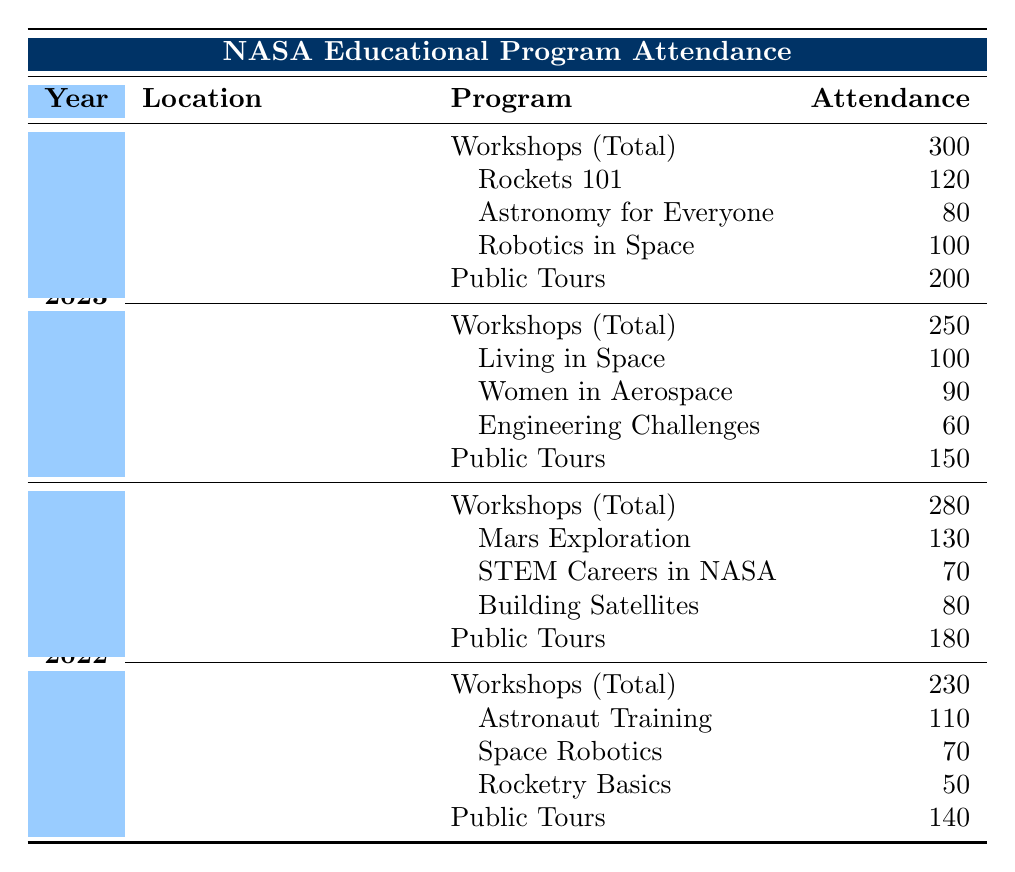What was the total attendance for workshops at Kennedy Space Center in 2023? The table shows that for 2023 at Kennedy Space Center, the total attendance for workshops is 300.
Answer: 300 How many attendees participated in the "Women in Aerospace" program at Johnson Space Center in 2023? Referring to the table for 2023 at Johnson Space Center, the attendance for the "Women in Aerospace" program is listed as 90.
Answer: 90 Which year had higher public tour attendance at the Kennedy Space Center, 2022 or 2023? The public tour attendance for 2022 was 180 and for 2023 was 200. Since 200 is greater than 180, 2023 had higher public tour attendance.
Answer: 2023 What is the total attendance for all workshops held at the Johnson Space Center in 2022? Looking at the workshops attendance for 2022 at Johnson Space Center, we see a total of 230. The individual programs had attendances of 110, 70, and 50, which add up to 230, verifying the total.
Answer: 230 Did the "Rockets 101" program have a higher attendance than the "Mars Exploration" program in 2023? The "Rockets 101" program had an attendance of 120, while "Mars Exploration" had 130 in 2022. Comparing them directly, 120 is less than 130, thus "Rockets 101" did not have higher attendance.
Answer: No What is the average attendance for public tours at both space centers in 2023? The public tour attendance in 2023 was 200 at Kennedy Space Center and 150 at Johnson Space Center. The average is calculated as (200 + 150) / 2 = 175.
Answer: 175 What is the total attendance for all programs at Kennedy Space Center in 2022? The workshops had a total attendance of 280, and public tours had 180, so the overall total is 280 + 180 = 460 for 2022 at Kennedy Space Center.
Answer: 460 Was the combined attendance for workshops across both years at the Johnson Space Center greater than 500? The total attendance for workshops in 2022 is 230 and for 2023 is 250. Adding these, 230 + 250 = 480, which is not greater than 500.
Answer: No How many more attendees participated in workshops at the Kennedy Space Center in 2023 compared to 2022? The attendance for workshops in 2023 was 300 and in 2022 was 280. The difference is 300 - 280 = 20, meaning there were 20 more attendees in 2023.
Answer: 20 